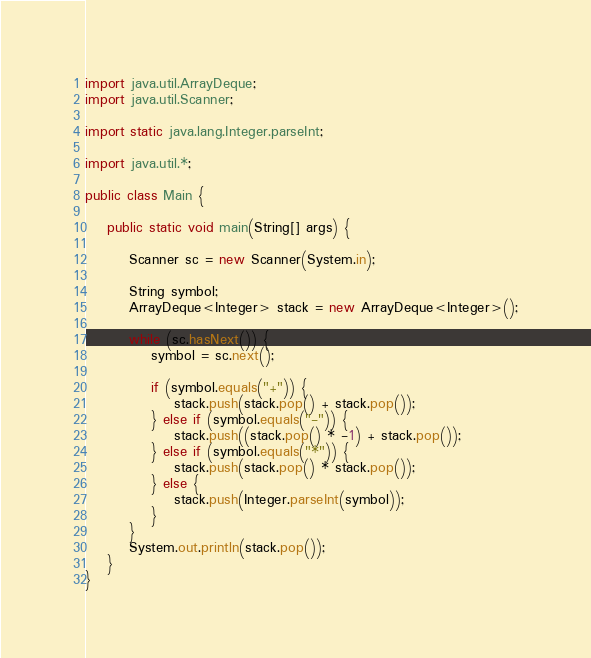Convert code to text. <code><loc_0><loc_0><loc_500><loc_500><_Java_>import java.util.ArrayDeque;
import java.util.Scanner;

import static java.lang.Integer.parseInt;

import java.util.*;

public class Main {

    public static void main(String[] args) {

        Scanner sc = new Scanner(System.in);

        String symbol;
        ArrayDeque<Integer> stack = new ArrayDeque<Integer>();

        while (sc.hasNext()) {
            symbol = sc.next();

            if (symbol.equals("+")) {
                stack.push(stack.pop() + stack.pop());
            } else if (symbol.equals("-")) {
                stack.push((stack.pop() * -1) + stack.pop());
            } else if (symbol.equals("*")) {
                stack.push(stack.pop() * stack.pop());
            } else {
                stack.push(Integer.parseInt(symbol));
            }
        }
        System.out.println(stack.pop());
    }
}
</code> 